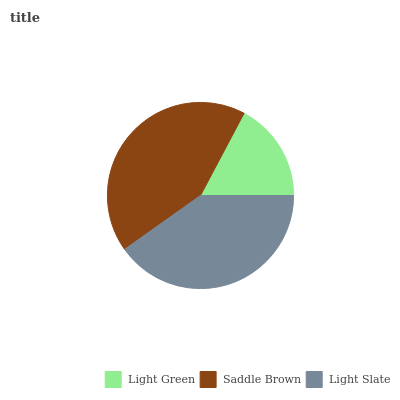Is Light Green the minimum?
Answer yes or no. Yes. Is Saddle Brown the maximum?
Answer yes or no. Yes. Is Light Slate the minimum?
Answer yes or no. No. Is Light Slate the maximum?
Answer yes or no. No. Is Saddle Brown greater than Light Slate?
Answer yes or no. Yes. Is Light Slate less than Saddle Brown?
Answer yes or no. Yes. Is Light Slate greater than Saddle Brown?
Answer yes or no. No. Is Saddle Brown less than Light Slate?
Answer yes or no. No. Is Light Slate the high median?
Answer yes or no. Yes. Is Light Slate the low median?
Answer yes or no. Yes. Is Saddle Brown the high median?
Answer yes or no. No. Is Light Green the low median?
Answer yes or no. No. 